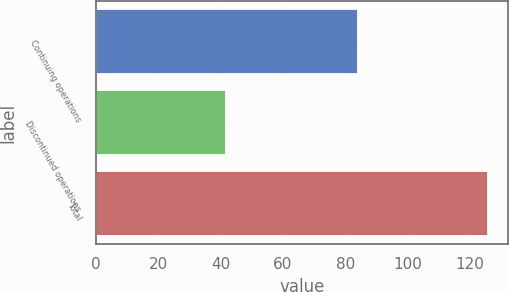Convert chart to OTSL. <chart><loc_0><loc_0><loc_500><loc_500><bar_chart><fcel>Continuing operations<fcel>Discontinued operations<fcel>Total<nl><fcel>84.1<fcel>41.7<fcel>125.8<nl></chart> 